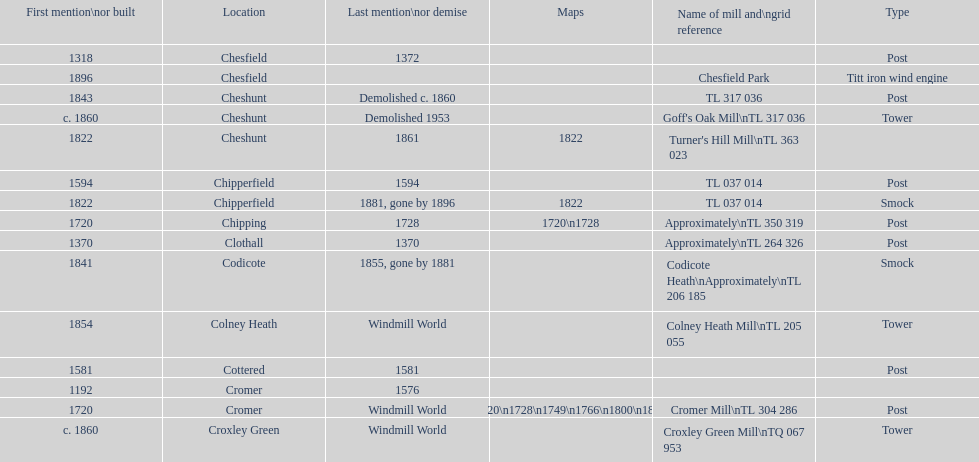What is the number of mills first mentioned or built in the 1800s? 8. 